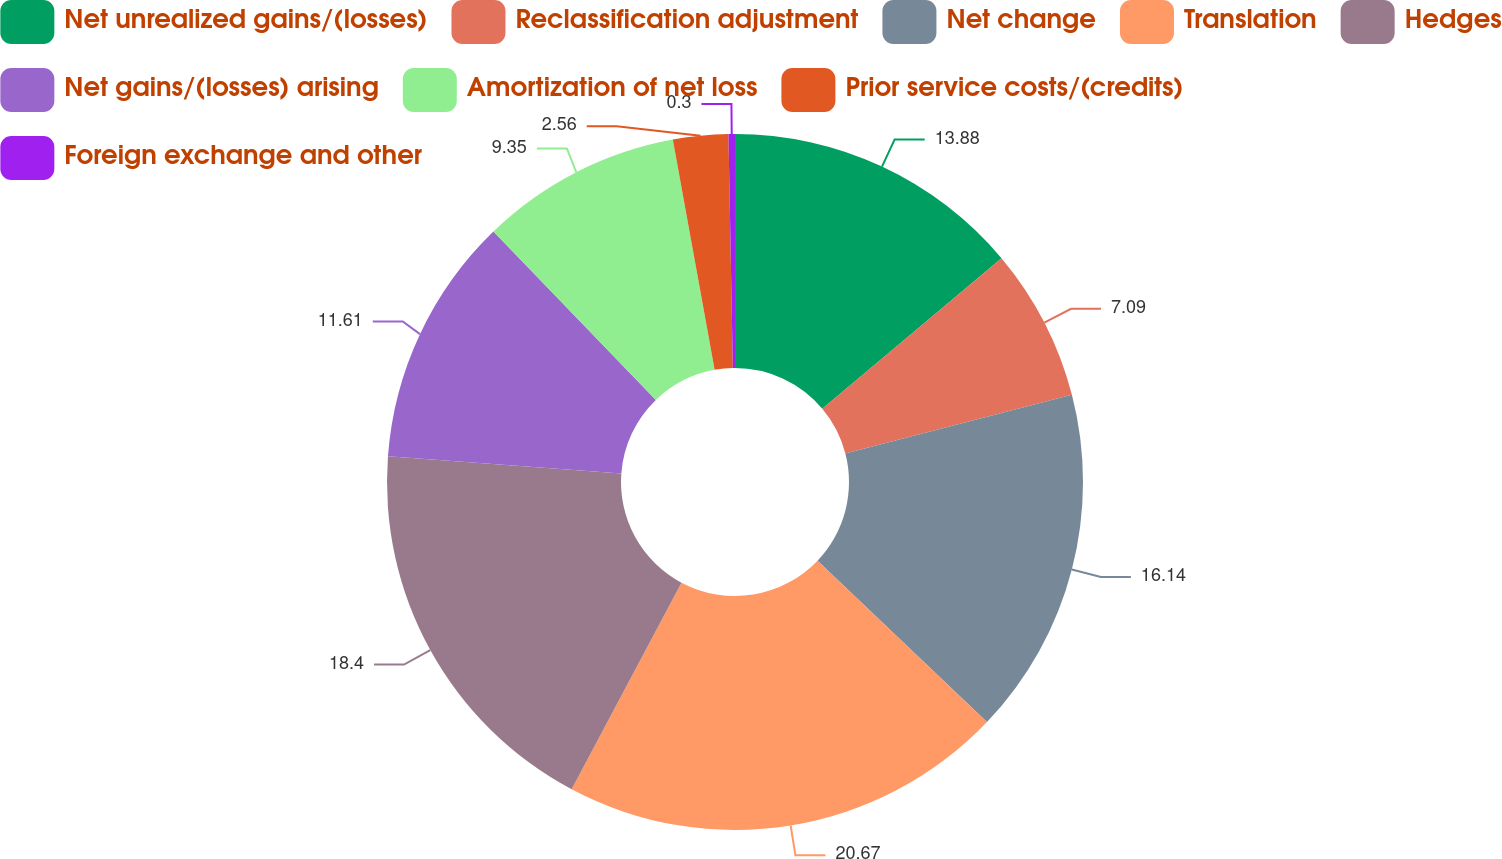Convert chart to OTSL. <chart><loc_0><loc_0><loc_500><loc_500><pie_chart><fcel>Net unrealized gains/(losses)<fcel>Reclassification adjustment<fcel>Net change<fcel>Translation<fcel>Hedges<fcel>Net gains/(losses) arising<fcel>Amortization of net loss<fcel>Prior service costs/(credits)<fcel>Foreign exchange and other<nl><fcel>13.88%<fcel>7.09%<fcel>16.14%<fcel>20.66%<fcel>18.4%<fcel>11.61%<fcel>9.35%<fcel>2.56%<fcel>0.3%<nl></chart> 